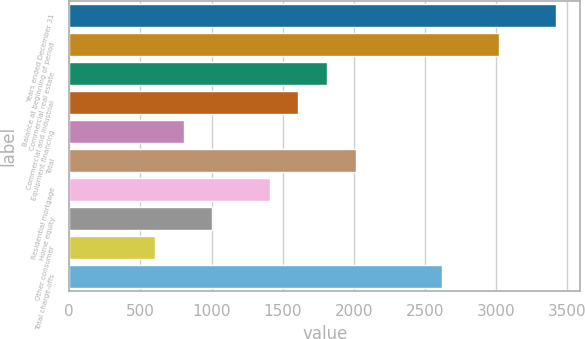Convert chart. <chart><loc_0><loc_0><loc_500><loc_500><bar_chart><fcel>Years ended December 31<fcel>Balance at beginning of period<fcel>Commercial real estate<fcel>Commercial and industrial<fcel>Equipment financing<fcel>Total<fcel>Residential mortgage<fcel>Home equity<fcel>Other consumer<fcel>Total charge-offs<nl><fcel>3420.08<fcel>3017.76<fcel>1810.8<fcel>1609.64<fcel>805<fcel>2011.96<fcel>1408.48<fcel>1006.16<fcel>603.84<fcel>2615.44<nl></chart> 